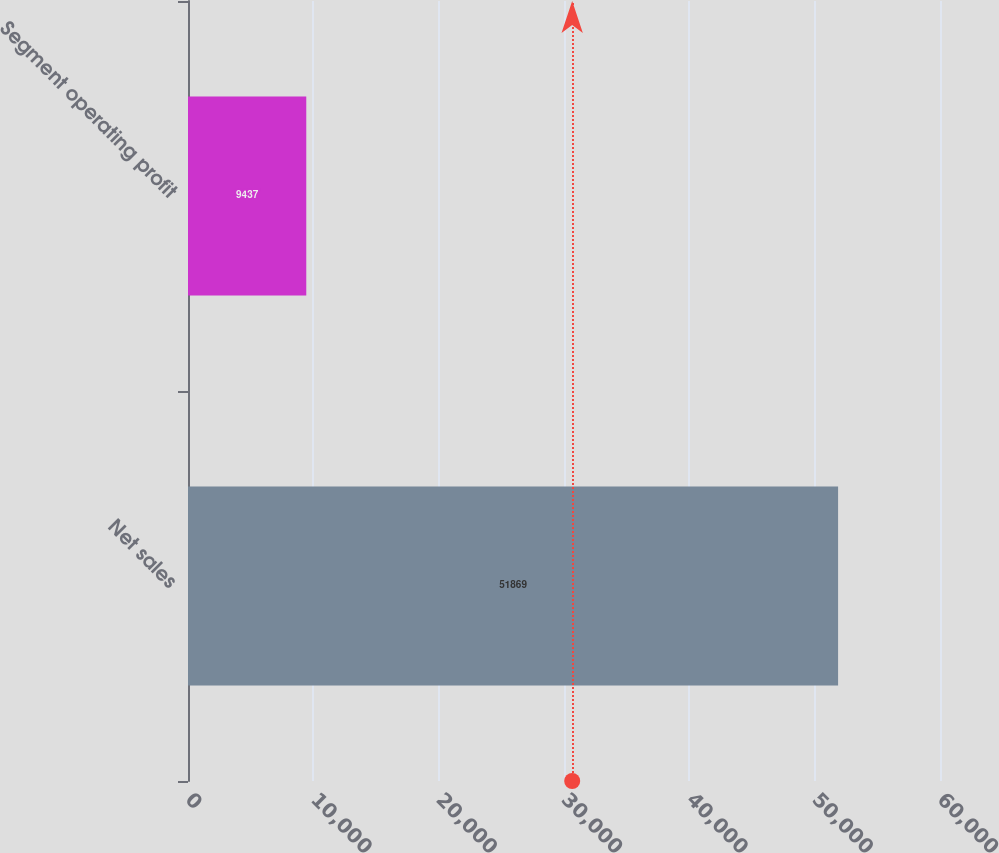<chart> <loc_0><loc_0><loc_500><loc_500><bar_chart><fcel>Net sales<fcel>Segment operating profit<nl><fcel>51869<fcel>9437<nl></chart> 